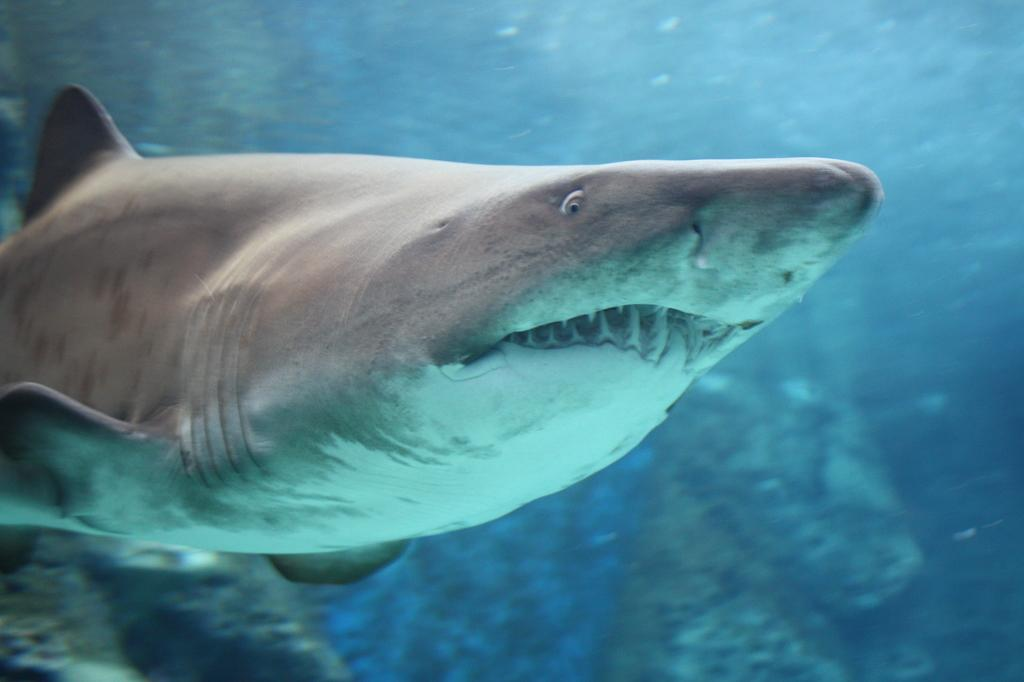What type of animals can be seen in the water in the image? There are sharks in the water in the image. What can be seen in the background of the image? There are rocks visible in the background of the image. What type of clock is visible on the face of one of the sharks in the image? There is no clock or face present on any of the sharks in the image. 